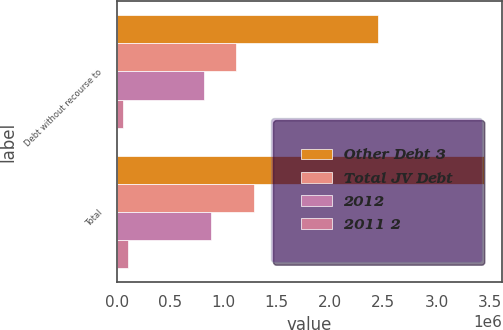<chart> <loc_0><loc_0><loc_500><loc_500><stacked_bar_chart><ecel><fcel>Debt without recourse to<fcel>Total<nl><fcel>Other Debt 3<fcel>2.45005e+06<fcel>3.44008e+06<nl><fcel>Total JV Debt<fcel>1.11197e+06<fcel>1.28482e+06<nl><fcel>2012<fcel>815481<fcel>883718<nl><fcel>2011 2<fcel>58082<fcel>106509<nl></chart> 